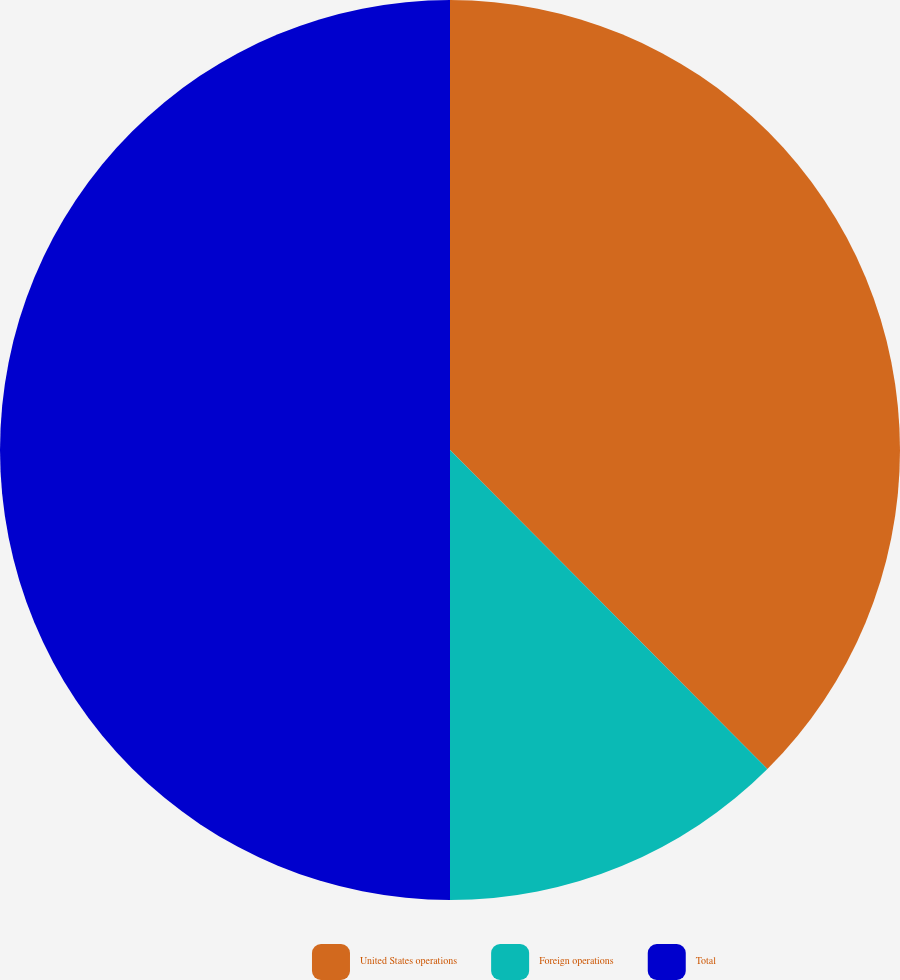Convert chart. <chart><loc_0><loc_0><loc_500><loc_500><pie_chart><fcel>United States operations<fcel>Foreign operations<fcel>Total<nl><fcel>37.54%<fcel>12.46%<fcel>50.0%<nl></chart> 